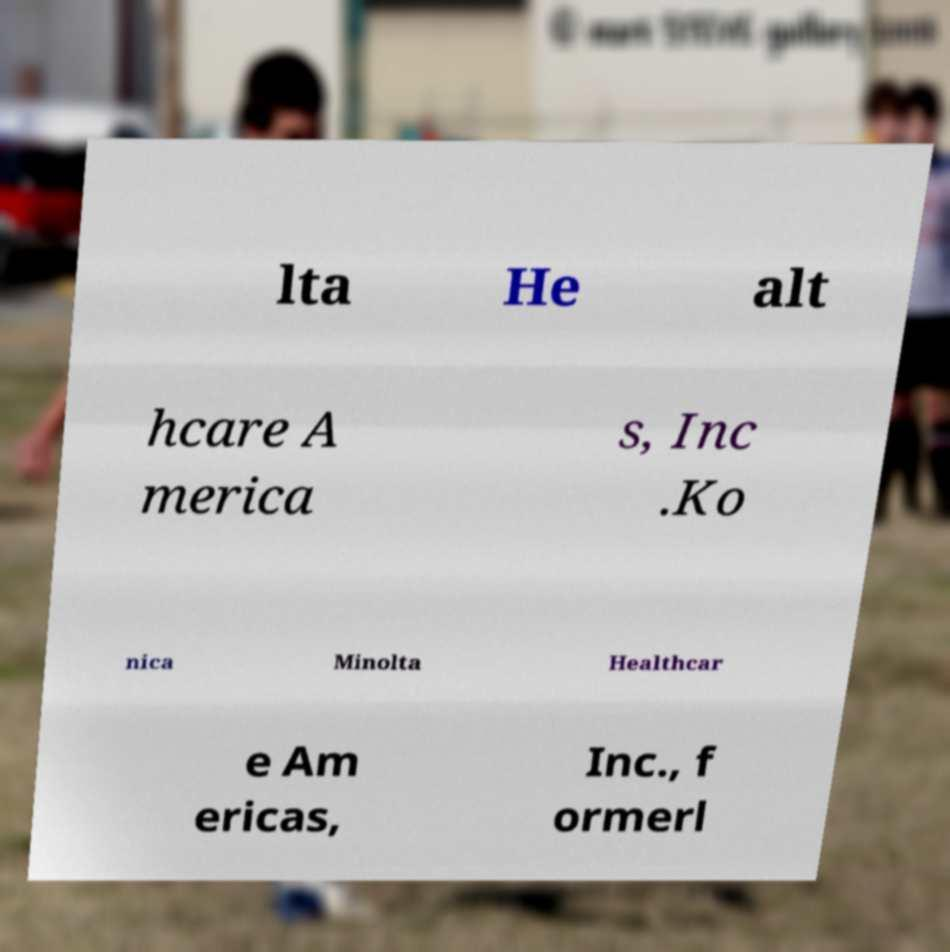There's text embedded in this image that I need extracted. Can you transcribe it verbatim? lta He alt hcare A merica s, Inc .Ko nica Minolta Healthcar e Am ericas, Inc., f ormerl 